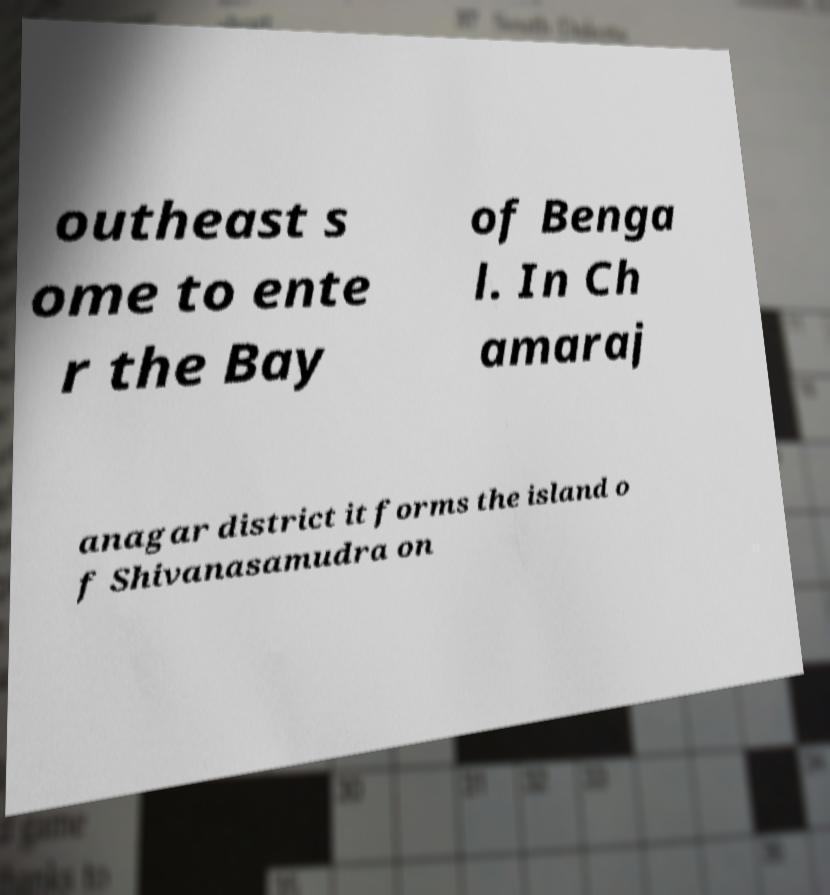Could you extract and type out the text from this image? outheast s ome to ente r the Bay of Benga l. In Ch amaraj anagar district it forms the island o f Shivanasamudra on 